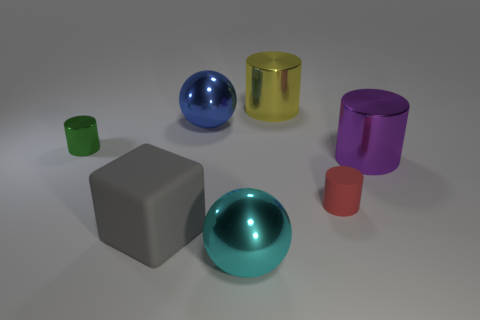What number of things are either purple metallic cylinders or cylinders right of the red matte cylinder?
Provide a short and direct response. 1. The blue shiny object that is the same size as the gray thing is what shape?
Your answer should be very brief. Sphere. How many tiny cylinders are the same color as the large matte block?
Offer a terse response. 0. Do the small object behind the small rubber cylinder and the big yellow object have the same material?
Your answer should be very brief. Yes. What shape is the large gray thing?
Offer a very short reply. Cube. How many gray things are metallic cylinders or matte blocks?
Your answer should be very brief. 1. How many other things are the same material as the large blue thing?
Keep it short and to the point. 4. There is a tiny object to the right of the gray object; is its shape the same as the gray rubber thing?
Offer a terse response. No. Are there any big blue objects?
Your answer should be very brief. Yes. Is there any other thing that has the same shape as the gray rubber thing?
Make the answer very short. No. 